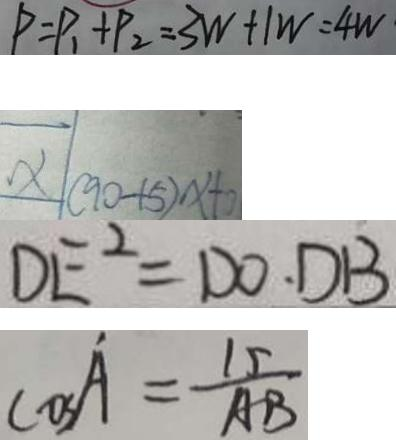Convert formula to latex. <formula><loc_0><loc_0><loc_500><loc_500>P = P _ { 1 } + P _ { 2 } = 3 W + 1 W = 4 W 
 x ( 9 0 - 1 5 ) x + 0 
 D E ^ { 2 } = D O \cdot D B 
 \cos A = \frac { 1 5 } { A B }</formula> 